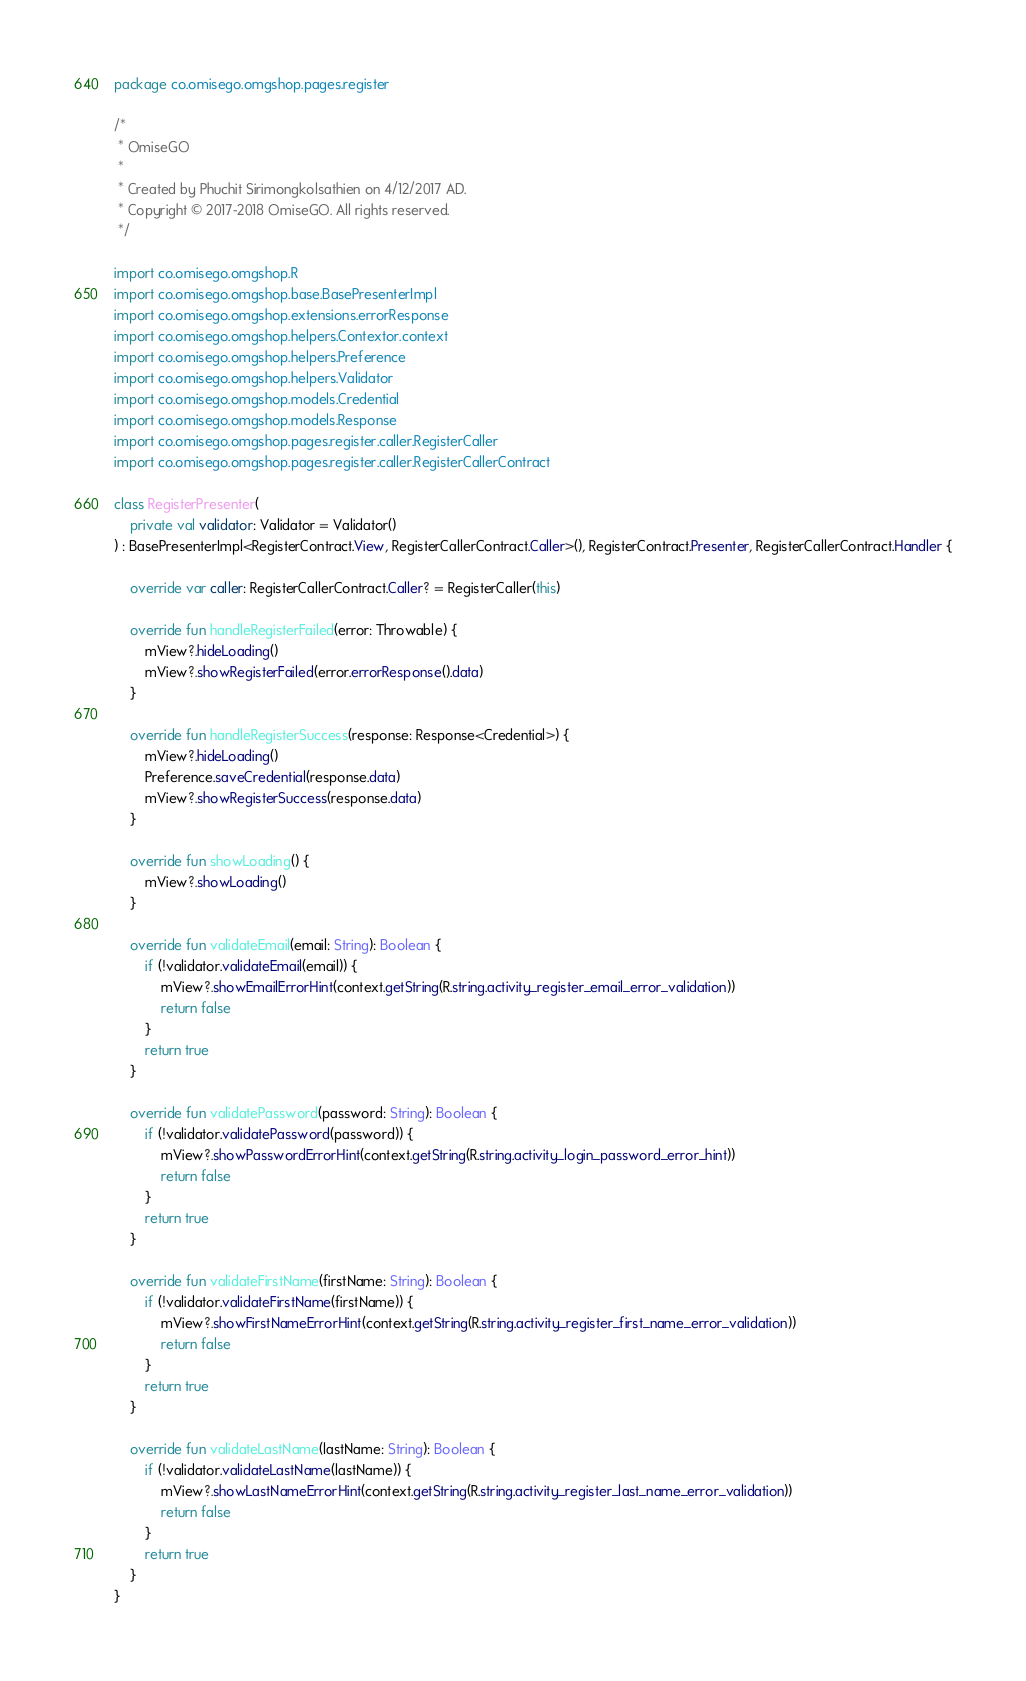Convert code to text. <code><loc_0><loc_0><loc_500><loc_500><_Kotlin_>package co.omisego.omgshop.pages.register

/*
 * OmiseGO
 *
 * Created by Phuchit Sirimongkolsathien on 4/12/2017 AD.
 * Copyright © 2017-2018 OmiseGO. All rights reserved.
 */

import co.omisego.omgshop.R
import co.omisego.omgshop.base.BasePresenterImpl
import co.omisego.omgshop.extensions.errorResponse
import co.omisego.omgshop.helpers.Contextor.context
import co.omisego.omgshop.helpers.Preference
import co.omisego.omgshop.helpers.Validator
import co.omisego.omgshop.models.Credential
import co.omisego.omgshop.models.Response
import co.omisego.omgshop.pages.register.caller.RegisterCaller
import co.omisego.omgshop.pages.register.caller.RegisterCallerContract

class RegisterPresenter(
    private val validator: Validator = Validator()
) : BasePresenterImpl<RegisterContract.View, RegisterCallerContract.Caller>(), RegisterContract.Presenter, RegisterCallerContract.Handler {

    override var caller: RegisterCallerContract.Caller? = RegisterCaller(this)

    override fun handleRegisterFailed(error: Throwable) {
        mView?.hideLoading()
        mView?.showRegisterFailed(error.errorResponse().data)
    }

    override fun handleRegisterSuccess(response: Response<Credential>) {
        mView?.hideLoading()
        Preference.saveCredential(response.data)
        mView?.showRegisterSuccess(response.data)
    }

    override fun showLoading() {
        mView?.showLoading()
    }

    override fun validateEmail(email: String): Boolean {
        if (!validator.validateEmail(email)) {
            mView?.showEmailErrorHint(context.getString(R.string.activity_register_email_error_validation))
            return false
        }
        return true
    }

    override fun validatePassword(password: String): Boolean {
        if (!validator.validatePassword(password)) {
            mView?.showPasswordErrorHint(context.getString(R.string.activity_login_password_error_hint))
            return false
        }
        return true
    }

    override fun validateFirstName(firstName: String): Boolean {
        if (!validator.validateFirstName(firstName)) {
            mView?.showFirstNameErrorHint(context.getString(R.string.activity_register_first_name_error_validation))
            return false
        }
        return true
    }

    override fun validateLastName(lastName: String): Boolean {
        if (!validator.validateLastName(lastName)) {
            mView?.showLastNameErrorHint(context.getString(R.string.activity_register_last_name_error_validation))
            return false
        }
        return true
    }
}</code> 